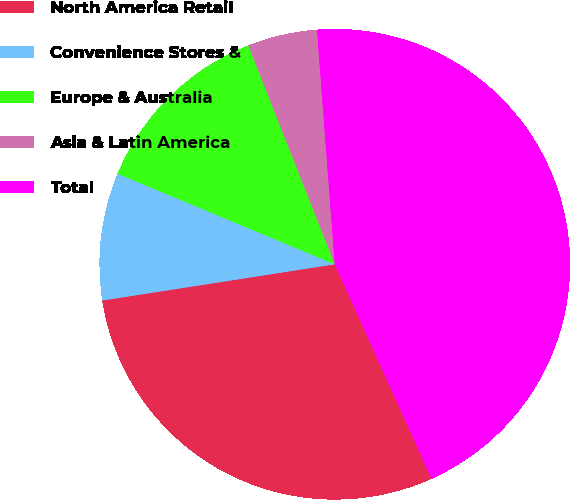Convert chart to OTSL. <chart><loc_0><loc_0><loc_500><loc_500><pie_chart><fcel>North America Retail<fcel>Convenience Stores &<fcel>Europe & Australia<fcel>Asia & Latin America<fcel>Total<nl><fcel>29.28%<fcel>8.75%<fcel>12.72%<fcel>4.78%<fcel>44.46%<nl></chart> 